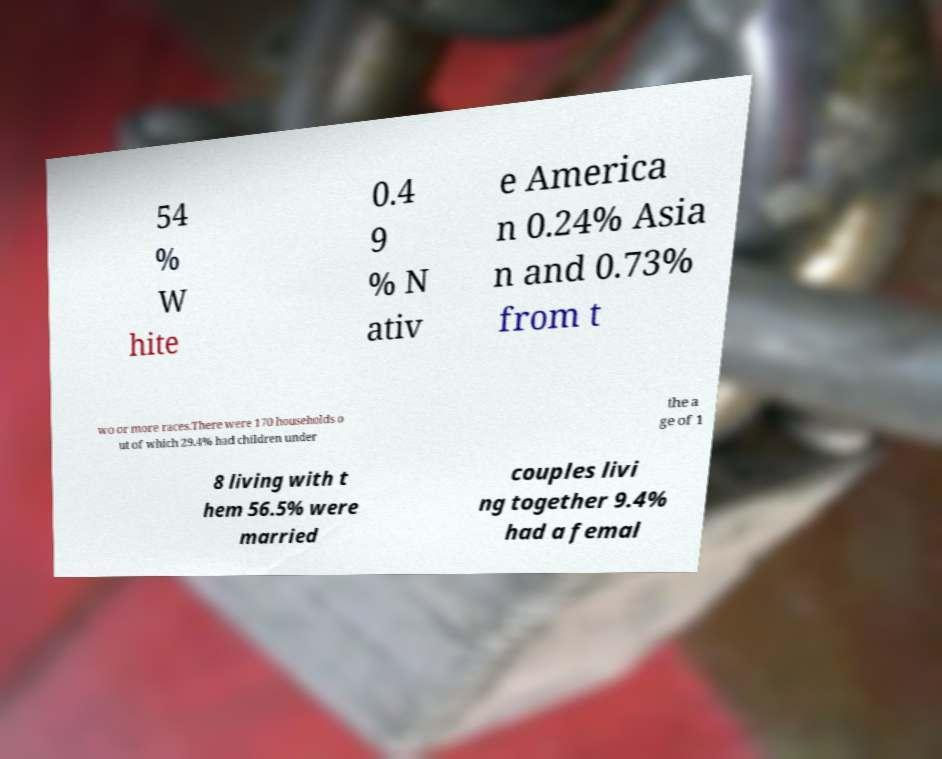Could you extract and type out the text from this image? 54 % W hite 0.4 9 % N ativ e America n 0.24% Asia n and 0.73% from t wo or more races.There were 170 households o ut of which 29.4% had children under the a ge of 1 8 living with t hem 56.5% were married couples livi ng together 9.4% had a femal 